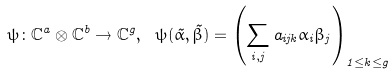<formula> <loc_0><loc_0><loc_500><loc_500>\psi \colon \mathbb { C } ^ { a } \otimes \mathbb { C } ^ { b } \to \mathbb { C } ^ { g } , \ \psi ( \vec { \alpha } , \vec { \beta } ) = \left ( \sum _ { i , j } a _ { i j k } \alpha _ { i } \beta _ { j } \right ) _ { 1 \leq k \leq g }</formula> 